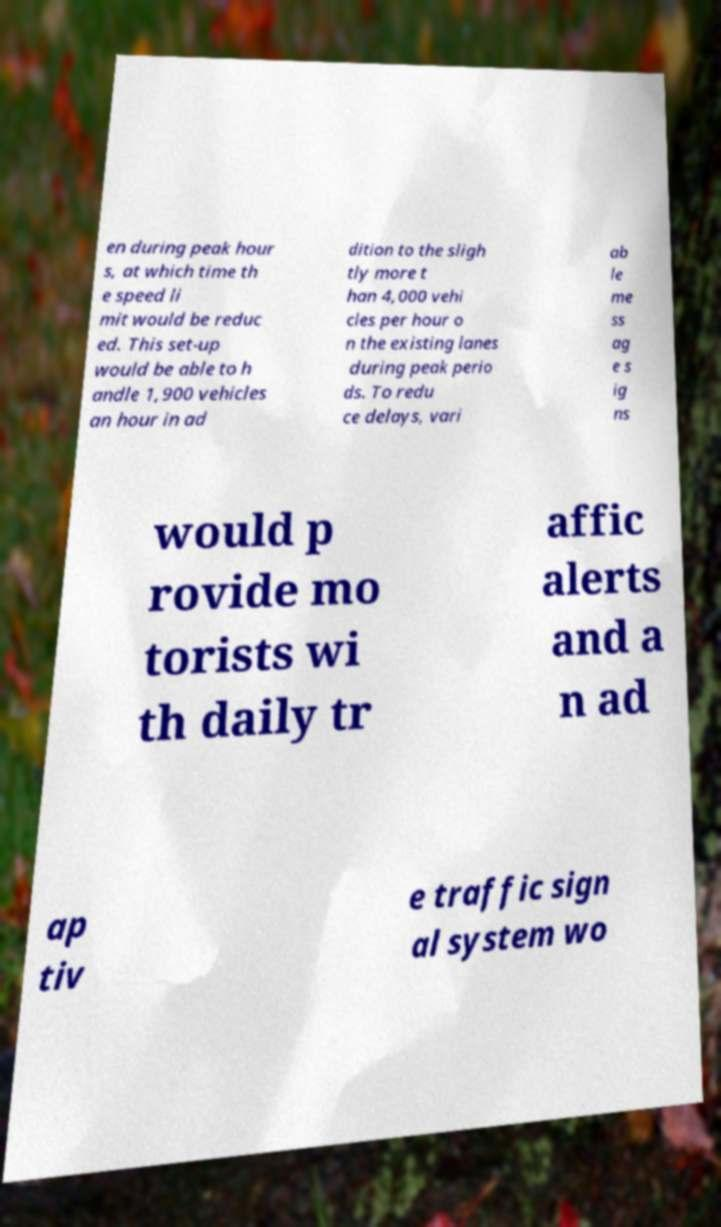What messages or text are displayed in this image? I need them in a readable, typed format. en during peak hour s, at which time th e speed li mit would be reduc ed. This set-up would be able to h andle 1,900 vehicles an hour in ad dition to the sligh tly more t han 4,000 vehi cles per hour o n the existing lanes during peak perio ds. To redu ce delays, vari ab le me ss ag e s ig ns would p rovide mo torists wi th daily tr affic alerts and a n ad ap tiv e traffic sign al system wo 